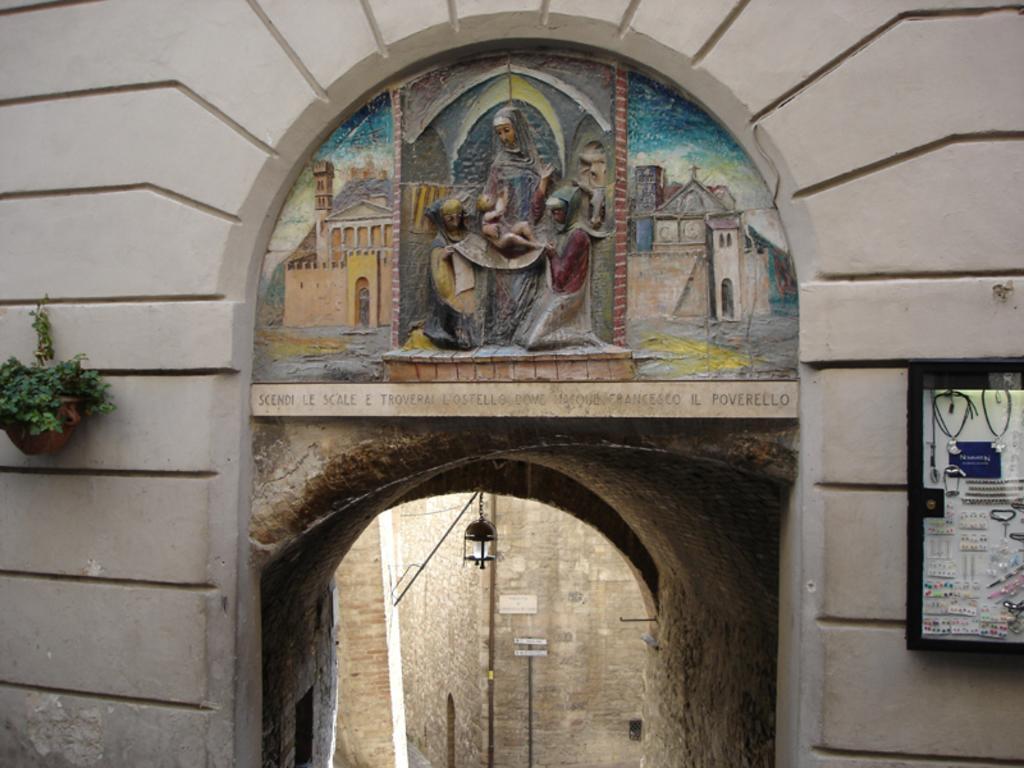Could you give a brief overview of what you see in this image? In the picture we can see the entrance wall on the top of it we can see the sculptures and beside the wall we can see a houseplant hanged to the wall. 